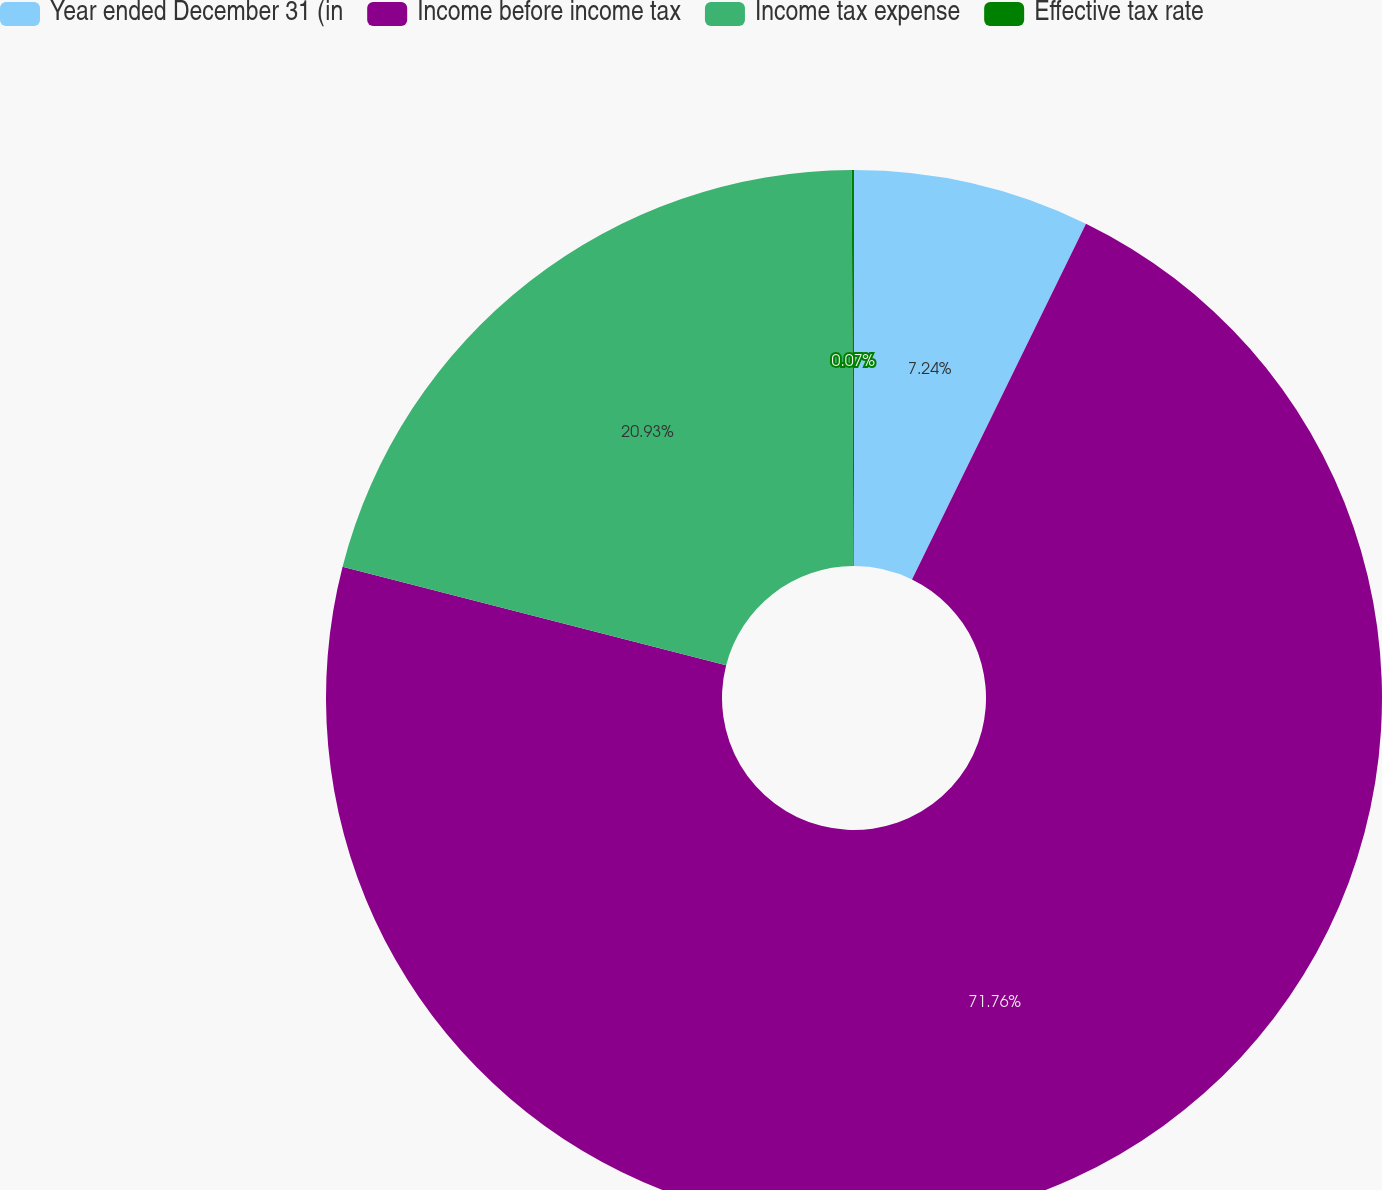Convert chart. <chart><loc_0><loc_0><loc_500><loc_500><pie_chart><fcel>Year ended December 31 (in<fcel>Income before income tax<fcel>Income tax expense<fcel>Effective tax rate<nl><fcel>7.24%<fcel>71.76%<fcel>20.93%<fcel>0.07%<nl></chart> 